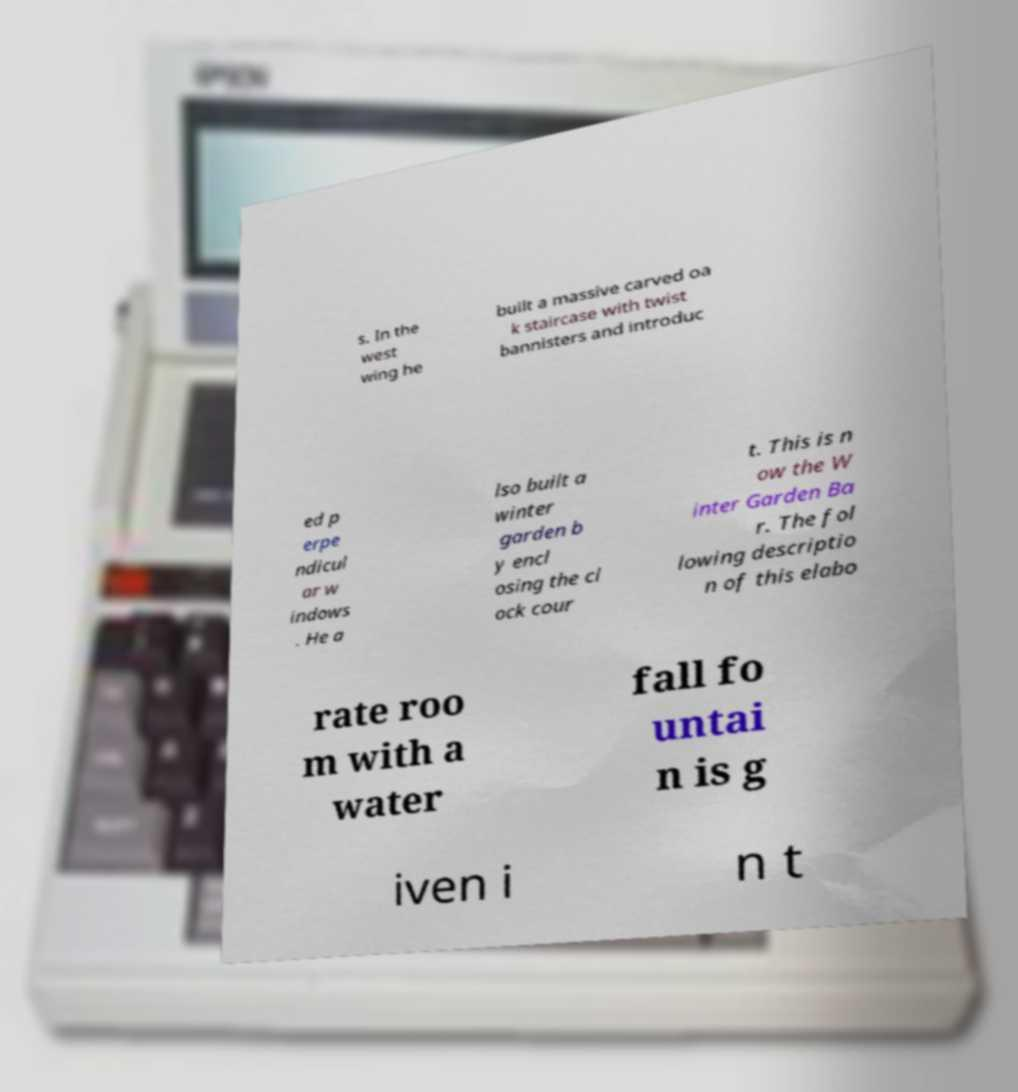Please identify and transcribe the text found in this image. s. In the west wing he built a massive carved oa k staircase with twist bannisters and introduc ed p erpe ndicul ar w indows . He a lso built a winter garden b y encl osing the cl ock cour t. This is n ow the W inter Garden Ba r. The fol lowing descriptio n of this elabo rate roo m with a water fall fo untai n is g iven i n t 